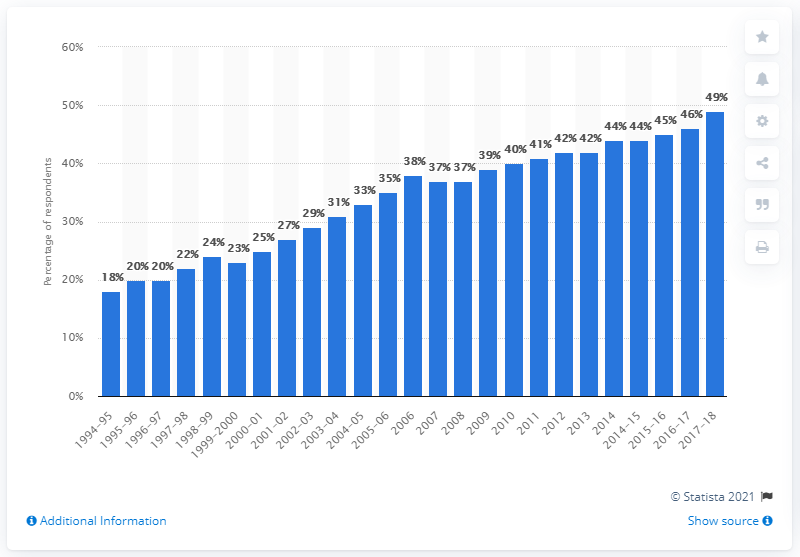Draw attention to some important aspects in this diagram. As of 2018, approximately 49% of households in the United States owned a dishwasher. 